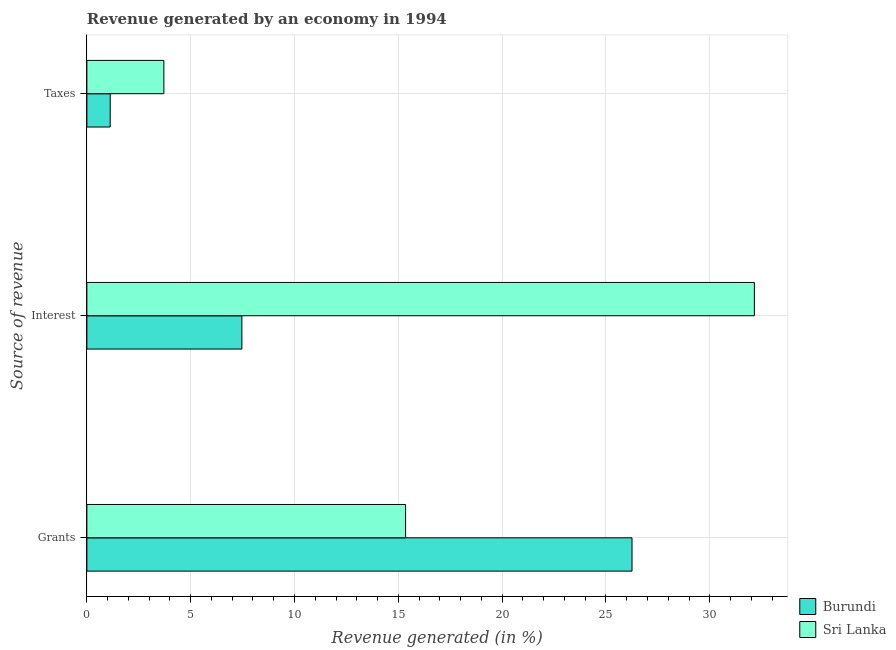How many different coloured bars are there?
Your answer should be compact. 2. How many groups of bars are there?
Your answer should be compact. 3. How many bars are there on the 3rd tick from the top?
Provide a short and direct response. 2. How many bars are there on the 3rd tick from the bottom?
Offer a terse response. 2. What is the label of the 1st group of bars from the top?
Make the answer very short. Taxes. What is the percentage of revenue generated by interest in Burundi?
Offer a very short reply. 7.47. Across all countries, what is the maximum percentage of revenue generated by interest?
Make the answer very short. 32.15. Across all countries, what is the minimum percentage of revenue generated by interest?
Make the answer very short. 7.47. In which country was the percentage of revenue generated by taxes maximum?
Provide a short and direct response. Sri Lanka. In which country was the percentage of revenue generated by grants minimum?
Ensure brevity in your answer.  Sri Lanka. What is the total percentage of revenue generated by grants in the graph?
Offer a terse response. 41.61. What is the difference between the percentage of revenue generated by taxes in Sri Lanka and that in Burundi?
Keep it short and to the point. 2.58. What is the difference between the percentage of revenue generated by interest in Sri Lanka and the percentage of revenue generated by grants in Burundi?
Offer a very short reply. 5.89. What is the average percentage of revenue generated by taxes per country?
Ensure brevity in your answer.  2.42. What is the difference between the percentage of revenue generated by interest and percentage of revenue generated by taxes in Burundi?
Your response must be concise. 6.34. What is the ratio of the percentage of revenue generated by grants in Sri Lanka to that in Burundi?
Your response must be concise. 0.58. Is the percentage of revenue generated by grants in Sri Lanka less than that in Burundi?
Keep it short and to the point. Yes. Is the difference between the percentage of revenue generated by grants in Burundi and Sri Lanka greater than the difference between the percentage of revenue generated by interest in Burundi and Sri Lanka?
Offer a very short reply. Yes. What is the difference between the highest and the second highest percentage of revenue generated by taxes?
Provide a short and direct response. 2.58. What is the difference between the highest and the lowest percentage of revenue generated by interest?
Your answer should be very brief. 24.68. In how many countries, is the percentage of revenue generated by taxes greater than the average percentage of revenue generated by taxes taken over all countries?
Your response must be concise. 1. What does the 2nd bar from the top in Taxes represents?
Your response must be concise. Burundi. What does the 1st bar from the bottom in Interest represents?
Provide a short and direct response. Burundi. Is it the case that in every country, the sum of the percentage of revenue generated by grants and percentage of revenue generated by interest is greater than the percentage of revenue generated by taxes?
Keep it short and to the point. Yes. How many bars are there?
Give a very brief answer. 6. Does the graph contain any zero values?
Make the answer very short. No. Where does the legend appear in the graph?
Your answer should be compact. Bottom right. How are the legend labels stacked?
Make the answer very short. Vertical. What is the title of the graph?
Your response must be concise. Revenue generated by an economy in 1994. What is the label or title of the X-axis?
Give a very brief answer. Revenue generated (in %). What is the label or title of the Y-axis?
Your answer should be very brief. Source of revenue. What is the Revenue generated (in %) of Burundi in Grants?
Keep it short and to the point. 26.26. What is the Revenue generated (in %) of Sri Lanka in Grants?
Your answer should be very brief. 15.35. What is the Revenue generated (in %) of Burundi in Interest?
Give a very brief answer. 7.47. What is the Revenue generated (in %) of Sri Lanka in Interest?
Provide a succinct answer. 32.15. What is the Revenue generated (in %) in Burundi in Taxes?
Ensure brevity in your answer.  1.12. What is the Revenue generated (in %) in Sri Lanka in Taxes?
Provide a succinct answer. 3.71. Across all Source of revenue, what is the maximum Revenue generated (in %) in Burundi?
Give a very brief answer. 26.26. Across all Source of revenue, what is the maximum Revenue generated (in %) in Sri Lanka?
Give a very brief answer. 32.15. Across all Source of revenue, what is the minimum Revenue generated (in %) in Burundi?
Provide a short and direct response. 1.12. Across all Source of revenue, what is the minimum Revenue generated (in %) of Sri Lanka?
Offer a very short reply. 3.71. What is the total Revenue generated (in %) of Burundi in the graph?
Keep it short and to the point. 34.84. What is the total Revenue generated (in %) of Sri Lanka in the graph?
Provide a succinct answer. 51.21. What is the difference between the Revenue generated (in %) in Burundi in Grants and that in Interest?
Your answer should be compact. 18.79. What is the difference between the Revenue generated (in %) in Sri Lanka in Grants and that in Interest?
Your answer should be compact. -16.8. What is the difference between the Revenue generated (in %) of Burundi in Grants and that in Taxes?
Make the answer very short. 25.13. What is the difference between the Revenue generated (in %) of Sri Lanka in Grants and that in Taxes?
Ensure brevity in your answer.  11.64. What is the difference between the Revenue generated (in %) of Burundi in Interest and that in Taxes?
Your answer should be very brief. 6.34. What is the difference between the Revenue generated (in %) of Sri Lanka in Interest and that in Taxes?
Your answer should be compact. 28.44. What is the difference between the Revenue generated (in %) of Burundi in Grants and the Revenue generated (in %) of Sri Lanka in Interest?
Provide a succinct answer. -5.89. What is the difference between the Revenue generated (in %) of Burundi in Grants and the Revenue generated (in %) of Sri Lanka in Taxes?
Your response must be concise. 22.55. What is the difference between the Revenue generated (in %) of Burundi in Interest and the Revenue generated (in %) of Sri Lanka in Taxes?
Provide a short and direct response. 3.76. What is the average Revenue generated (in %) in Burundi per Source of revenue?
Give a very brief answer. 11.61. What is the average Revenue generated (in %) in Sri Lanka per Source of revenue?
Your response must be concise. 17.07. What is the difference between the Revenue generated (in %) of Burundi and Revenue generated (in %) of Sri Lanka in Grants?
Offer a terse response. 10.91. What is the difference between the Revenue generated (in %) of Burundi and Revenue generated (in %) of Sri Lanka in Interest?
Your response must be concise. -24.68. What is the difference between the Revenue generated (in %) in Burundi and Revenue generated (in %) in Sri Lanka in Taxes?
Ensure brevity in your answer.  -2.58. What is the ratio of the Revenue generated (in %) in Burundi in Grants to that in Interest?
Your answer should be very brief. 3.52. What is the ratio of the Revenue generated (in %) in Sri Lanka in Grants to that in Interest?
Ensure brevity in your answer.  0.48. What is the ratio of the Revenue generated (in %) of Burundi in Grants to that in Taxes?
Ensure brevity in your answer.  23.37. What is the ratio of the Revenue generated (in %) of Sri Lanka in Grants to that in Taxes?
Make the answer very short. 4.14. What is the ratio of the Revenue generated (in %) in Burundi in Interest to that in Taxes?
Offer a very short reply. 6.65. What is the ratio of the Revenue generated (in %) in Sri Lanka in Interest to that in Taxes?
Provide a succinct answer. 8.67. What is the difference between the highest and the second highest Revenue generated (in %) in Burundi?
Ensure brevity in your answer.  18.79. What is the difference between the highest and the second highest Revenue generated (in %) of Sri Lanka?
Provide a succinct answer. 16.8. What is the difference between the highest and the lowest Revenue generated (in %) in Burundi?
Offer a terse response. 25.13. What is the difference between the highest and the lowest Revenue generated (in %) in Sri Lanka?
Provide a short and direct response. 28.44. 